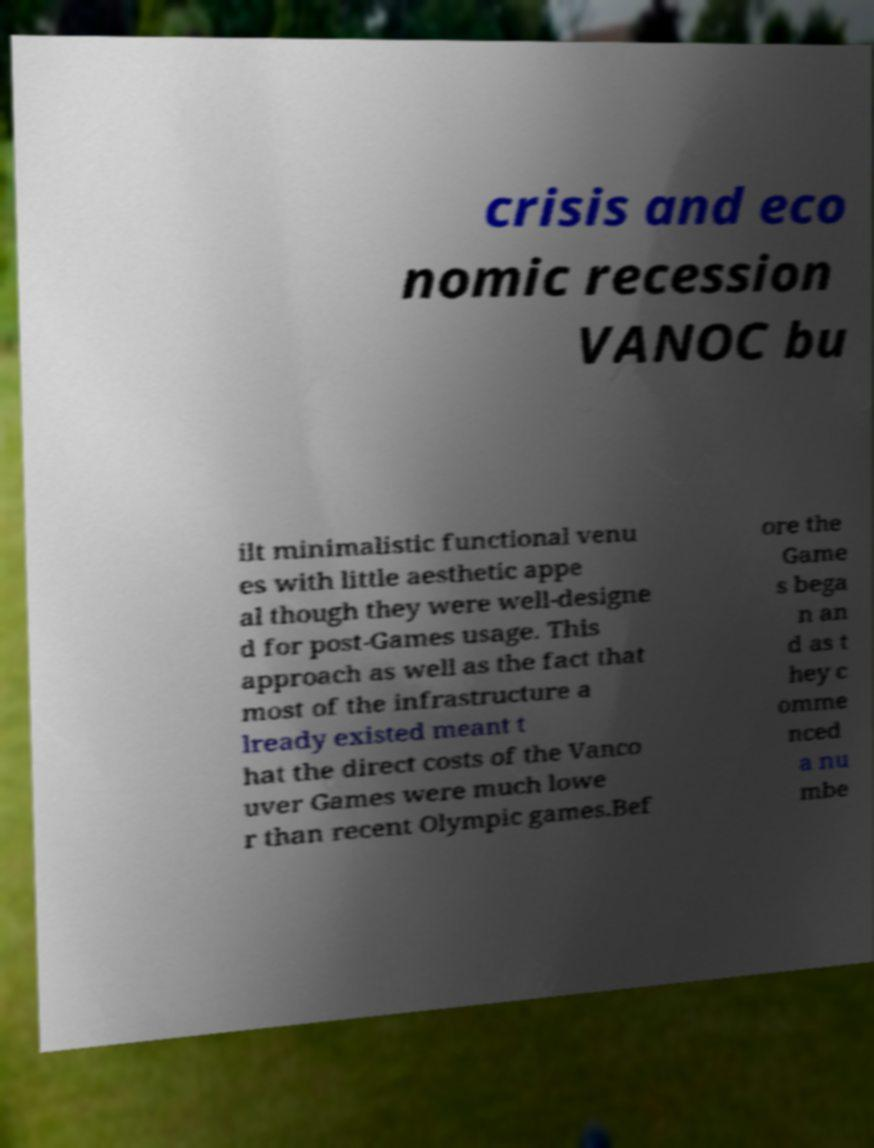For documentation purposes, I need the text within this image transcribed. Could you provide that? crisis and eco nomic recession VANOC bu ilt minimalistic functional venu es with little aesthetic appe al though they were well-designe d for post-Games usage. This approach as well as the fact that most of the infrastructure a lready existed meant t hat the direct costs of the Vanco uver Games were much lowe r than recent Olympic games.Bef ore the Game s bega n an d as t hey c omme nced a nu mbe 